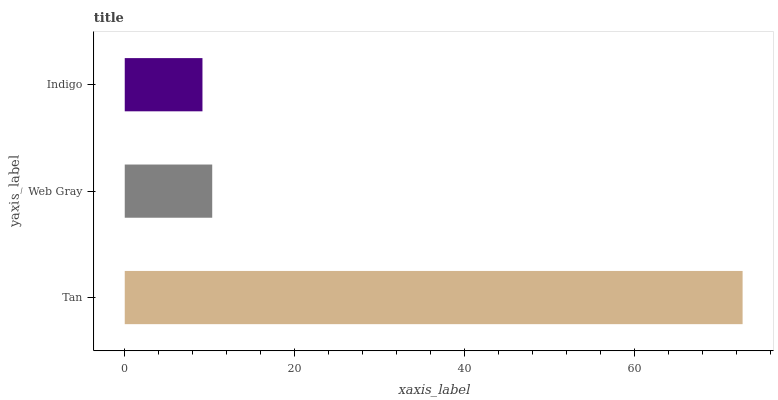Is Indigo the minimum?
Answer yes or no. Yes. Is Tan the maximum?
Answer yes or no. Yes. Is Web Gray the minimum?
Answer yes or no. No. Is Web Gray the maximum?
Answer yes or no. No. Is Tan greater than Web Gray?
Answer yes or no. Yes. Is Web Gray less than Tan?
Answer yes or no. Yes. Is Web Gray greater than Tan?
Answer yes or no. No. Is Tan less than Web Gray?
Answer yes or no. No. Is Web Gray the high median?
Answer yes or no. Yes. Is Web Gray the low median?
Answer yes or no. Yes. Is Tan the high median?
Answer yes or no. No. Is Indigo the low median?
Answer yes or no. No. 